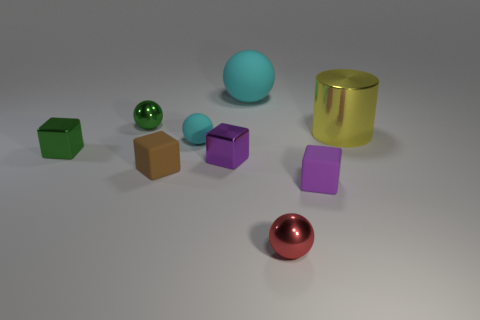Subtract all large spheres. How many spheres are left? 3 Subtract 3 cubes. How many cubes are left? 1 Add 1 small things. How many objects exist? 10 Subtract all purple blocks. How many blocks are left? 2 Subtract all blue blocks. Subtract all cyan cylinders. How many blocks are left? 4 Subtract all cyan cylinders. How many red cubes are left? 0 Subtract all small yellow rubber spheres. Subtract all big balls. How many objects are left? 8 Add 4 small matte spheres. How many small matte spheres are left? 5 Add 9 big metal cylinders. How many big metal cylinders exist? 10 Subtract 1 green spheres. How many objects are left? 8 